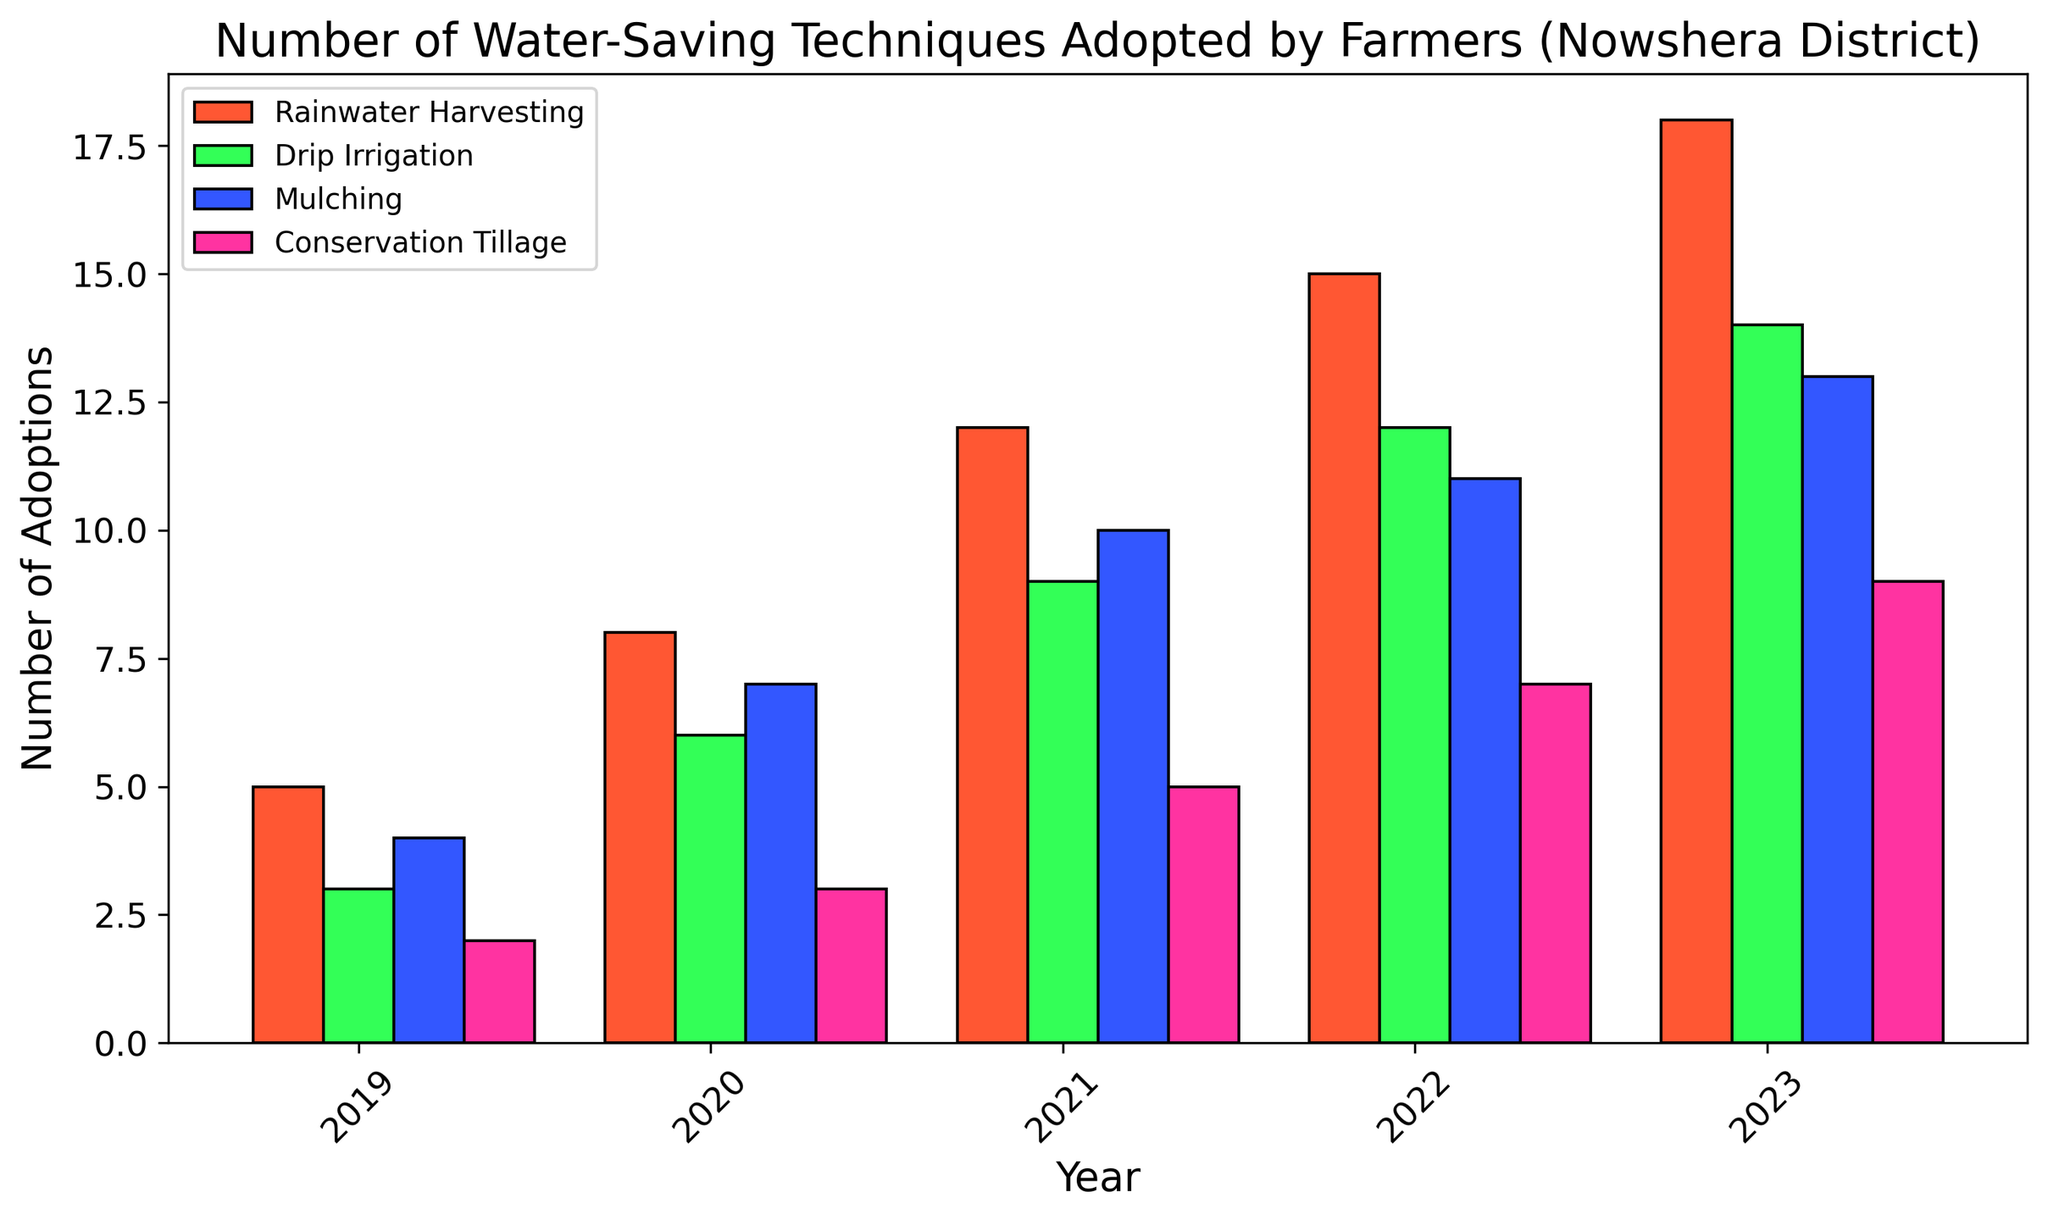How many techniques showed an increase in adoption every year from 2019 to 2023? By examining each technique individually, we see that Rainwater Harvesting, Drip Irrigation, Mulching, and Conservation Tillage all had an increasing trend in adoption each year. Therefore, all four techniques showed an increase every year.
Answer: 4 Which technique had the highest number of adoptions in 2023? By looking at the height of the bars in 2023, Rainwater Harvesting had the tallest bar, indicating the highest number of adoptions.
Answer: Rainwater Harvesting What is the total number of adoptions for Rainwater Harvesting from 2019 to 2023? Summing up the counts of Rainwater Harvesting from 2019 to 2023 gives 5 + 8 + 12 + 15 + 18. Therefore, the total is 58.
Answer: 58 Which year saw the biggest increase in Drip Irrigation adoptions compared to the previous year? By examining the bars for Drip Irrigation, the differences between consecutive years are as follows: 
2019-2020: 3
2020-2021: 3
2021-2022: 3
2022-2023: 2
Therefore, the biggest increase occurred between 2021 and 2022.
Answer: 2021-2022 For which technique did the number of adoptions in 2020 equate to half of the number of adoptions in 2023? Examining the bars, Rainwater Harvesting had 8 adoptions in 2020 and 18 in 2023, Drip Irrigation had 6 in 2020 and 14 in 2023, Mulching had 7 in 2020 and 13 in 2023, and Conservation Tillage had 3 in 2020 and 9 in 2023. None of these match the criteria exactly, as none of the 2020 adoptions are precisely half of the 2023 adoptions.
Answer: None What is the difference in the number of adoptions between the technique with the most adoptions and the technique with the least adoptions in 2022? In 2022, Rainwater Harvesting had 15 adoptions and Conservation Tillage had 7 adoptions. The difference is 15 - 7. Therefore, the difference is 8.
Answer: 8 On average, how many adoptions per year did Mulching receive from 2019 to 2023? Summing the counts for Mulching from 2019 to 2023 gives (4 + 7 + 10 + 11 + 13) = 45. The average over 5 years is 45 / 5 = 9.
Answer: 9 